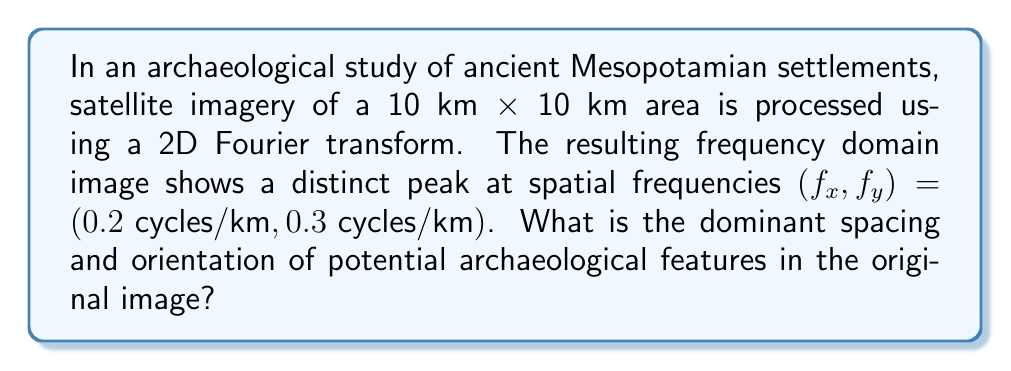Provide a solution to this math problem. To solve this problem, we need to understand how the Fourier transform relates spatial frequencies to physical features in the image. Let's break it down step-by-step:

1) The Fourier transform converts spatial information into frequency information. In this case, we have a 2D Fourier transform, which gives us spatial frequencies in both x and y directions.

2) The peak in the frequency domain at $(f_x, f_y) = (0.2 \text{ cycles/km}, 0.3 \text{ cycles/km})$ indicates a dominant periodic pattern in the original image.

3) To find the spacing of the features, we need to calculate the wavelength $\lambda$, which is the inverse of the frequency:

   $$\lambda_x = \frac{1}{f_x} = \frac{1}{0.2} = 5 \text{ km}$$
   $$\lambda_y = \frac{1}{f_y} = \frac{1}{0.3} \approx 3.33 \text{ km}$$

4) The dominant spacing is the magnitude of the vector $(\lambda_x, \lambda_y)$:

   $$\text{Spacing} = \sqrt{\lambda_x^2 + \lambda_y^2} = \sqrt{5^2 + 3.33^2} \approx 6.01 \text{ km}$$

5) To find the orientation, we calculate the angle $\theta$ with respect to the x-axis:

   $$\theta = \tan^{-1}\left(\frac{f_y}{f_x}\right) = \tan^{-1}\left(\frac{0.3}{0.2}\right) \approx 56.31°$$

6) The orientation perpendicular to this (which is the direction of the features) is:

   $$\text{Orientation} = 90° - 56.31° \approx 33.69°$$

Thus, the dominant spacing of potential archaeological features is approximately 6.01 km, and they are oriented at an angle of approximately 33.69° clockwise from the y-axis (or north, assuming the image is oriented with north at the top).
Answer: The dominant spacing of potential archaeological features is approximately 6.01 km, oriented at an angle of 33.69° clockwise from the y-axis. 